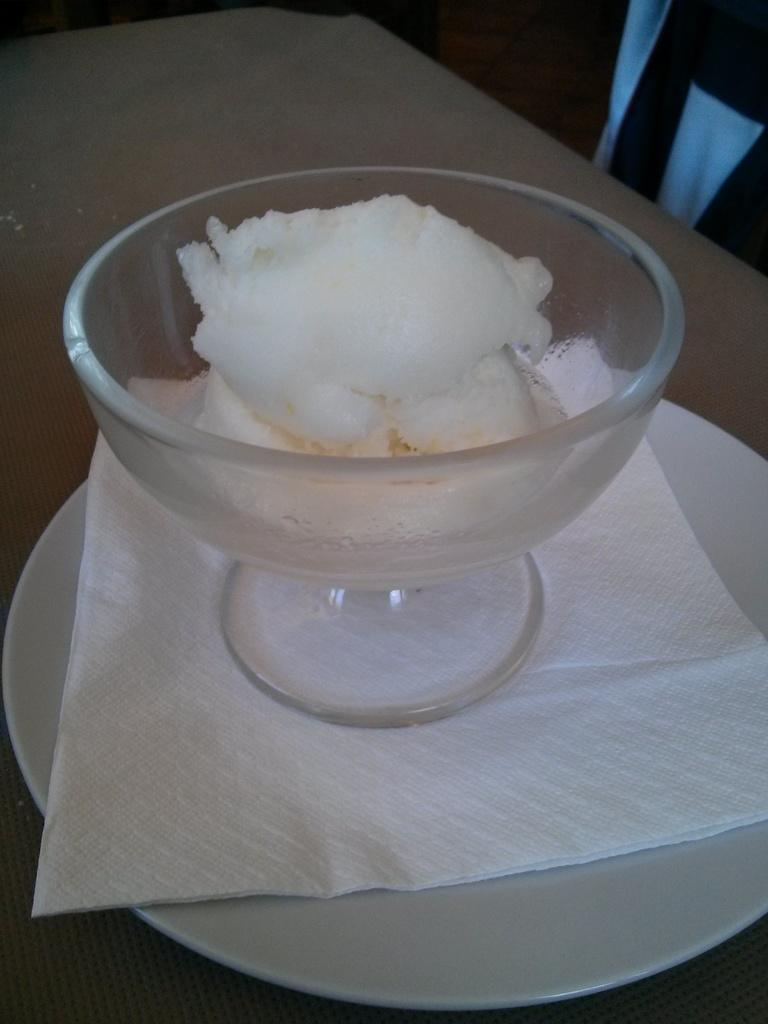What is in the bowl that is visible in the image? There is food in a bowl in the image. What other item can be seen in the image besides the bowl? There is a tissue paper in a plate in the image. Where is the plate located in the image? The plate is placed on a platform in the image. How many geese are present in the image? There are no geese present in the image. What room is the food being served in? The provided facts do not give any information about the room or location where the food is being served. 